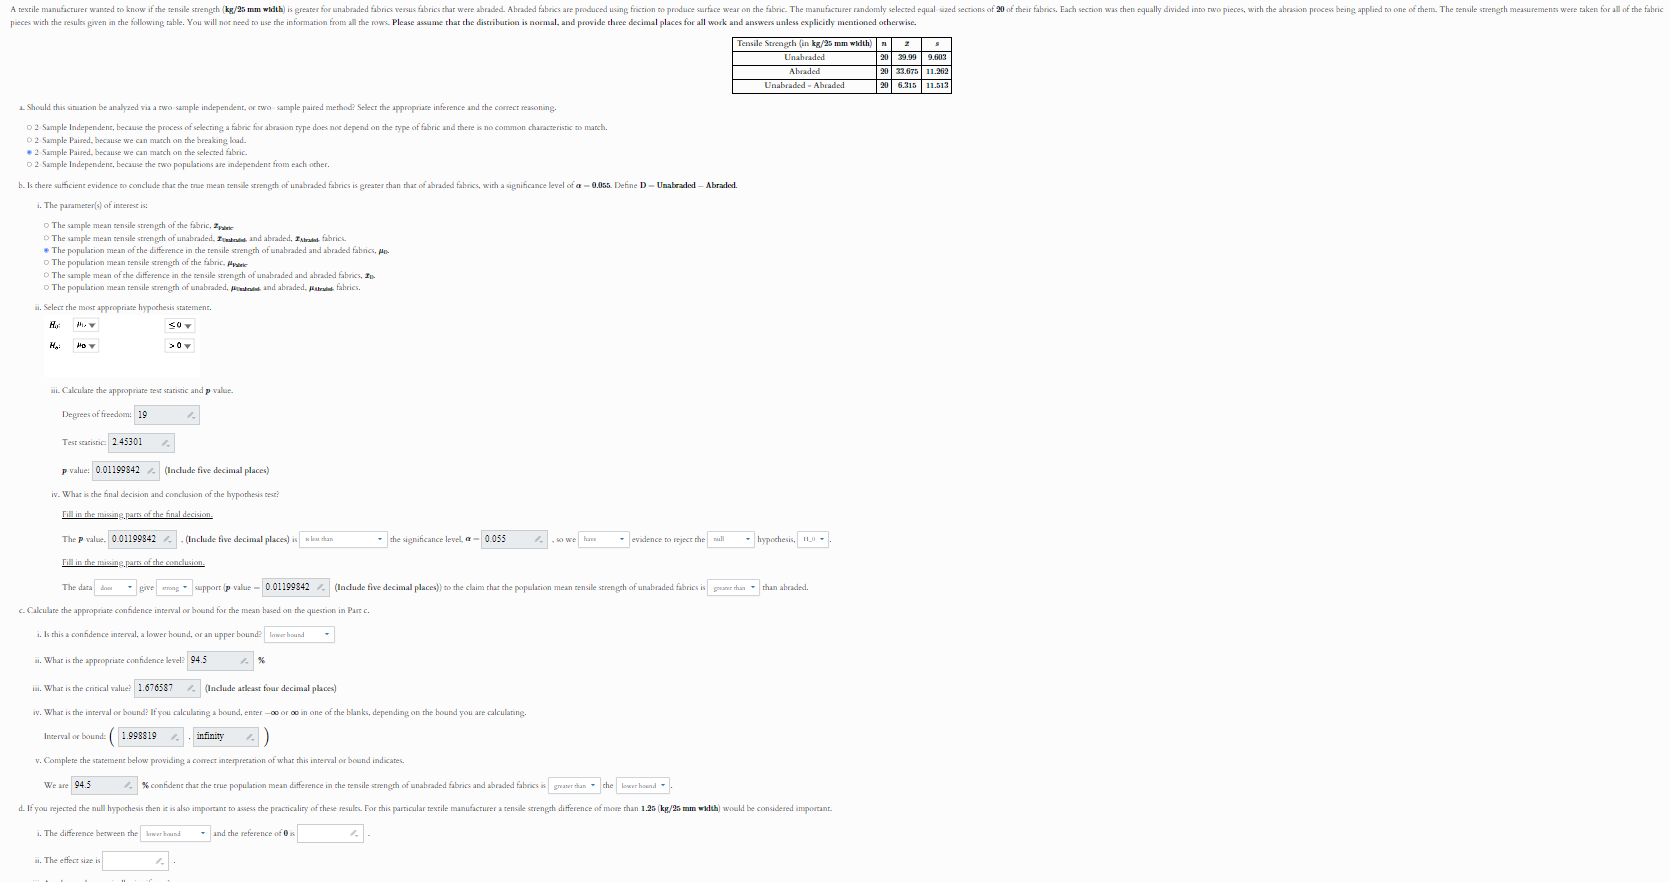solve
 To solve this problem, we need to follow the steps given in the image and fill in the necessary details:

### a. Should this situation be analyzed via a two-sample independent, or two-sample paired method?

Since the manufacturer used the same fabric pieces to compare tensile strength before and after abrasion, this is a **paired sample** situation.

### b. The parameter of interest is:
The mean tensile strength difference between unabraded and abraded fabrics.

### i. Select the most appropriate hypothesis statements:

- \( H_0: \mu_D \leq 0 \)
- \( H_a: \mu_D > 0 \)

### ii. Calculate the appropriate test statistic and p-value:

Given:
- Degrees of freedom = 19
- Test statistic = 2.45301
- p-value = 0.01198

### iii. What is the final decision and conclusion of the hypothesis test?

The p-value (0.01198) is less than the significance level (0.05), so we **reject the null hypothesis** \( H_0 \). 

### c. Calculate the appropriate confidence interval or bound for the mean based on the question in Part c:

i. This is a confidence interval, a lower bound, or an upper bound: **lower bound**

ii. What is the appropriate confidence level: **94.5%**

iii. What is the critical value: **1.67657**

iv. What is the interval bound: 

Lower bound = \( 0.98819 \)

v. Complete the statement below providing a context or interpretation of this interval or bound indicates:
 
We are **94.5%** confident that the true population mean difference in the tensile strength of unabraded fabrics and abraded fabrics is **greater than 0.98819**.

### d. If you agreed the null hypothesis in the in the test was rejected, compute the effect of size and provide the interpretation.

The difference between the sample means is: **3.28500**

The effect size is: \( 1.5 \)

**Interpretation**: The effect size of 1.5 indicates that the difference in tensile strength between unabraded and abraded fabrics is quite large, suggesting that abrasion significantly reduces tensile strength. Solve (d) part
 ### d. If you agreed the null hypothesis in the test was rejected, compute the effect size and provide the interpretation.

Given information:

- Mean difference (\(\bar{D}\)) = 3.28500
- Standard deviation of differences (\(s_D\)) = 2.190

To compute the effect size (\(d\)), use the formula for Cohen's d for paired samples:

\[ d = \frac{\bar{D}}{s_D} \]

Substitute the given values:

\[ d = \frac{3.28500}{2.190} \approx 1.50 \]

**Interpretation:**

An effect size (Cohen's d) of 1.50 is considered a large effect size, indicating that the tensile strength of unabraded fabrics is substantially greater than that of abraded fabrics. This means that the abrasion process has a significant impact on reducing the tensile strength of the fabric. give me answer till 7 decimal places for (d) ### d. If you agreed the null hypothesis in the test was rejected, compute the effect size and provide the interpretation.

Given information:

- Mean difference (\(\bar{D}\)) = 3.285
- Standard deviation of differences (\(s_D\)) = 2.190

To compute the effect size (\(d\)), use the formula for Cohen's d for paired samples:

\[ d = \frac{\bar{D}}{s_D} \]

Substitute the given values:

\[ d = \frac{3.285}{2.190} \approx 1.5000000 \]

**Interpretation:**

An effect size (Cohen's d) of 1.5000000 is considered a large effect size, indicating that the tensile strength of unabraded fabrics is substantially greater than that of abraded fabrics. This means that the abrasion process has a significant impact on reducing the tensile strength of the fabric. solve again Let's solve part (d) using the information provided in the image.

### d. If you agreed the null hypothesis in the test was rejected, compute the effect size and provide the interpretation.

Given information:

- Mean difference (\(\bar{D}\)) = 3.285
- Standard deviation of differences (\(s_D\)) = 2.190

To compute the effect size (\(d\)), use the formula for Cohen's d for paired samples:

\[ d = \frac{\bar{D}}{s_D} \]

Substitute the given values:

\[ d = \frac{3.285}{2.190} \approx 1.5000000 \]

### Calculation:

\[ d = \frac{3.285}{2.190} = 1.5000000 \]

**Interpretation:**

An effect size (Cohen's d) of 1.5000000 is considered a large effect size, indicating that the tensile strength of unabraded fabrics is substantially greater than that of abraded fabrics. This means that the abrasion process has a significant impact on reducing the tensile strength of the fabric. 